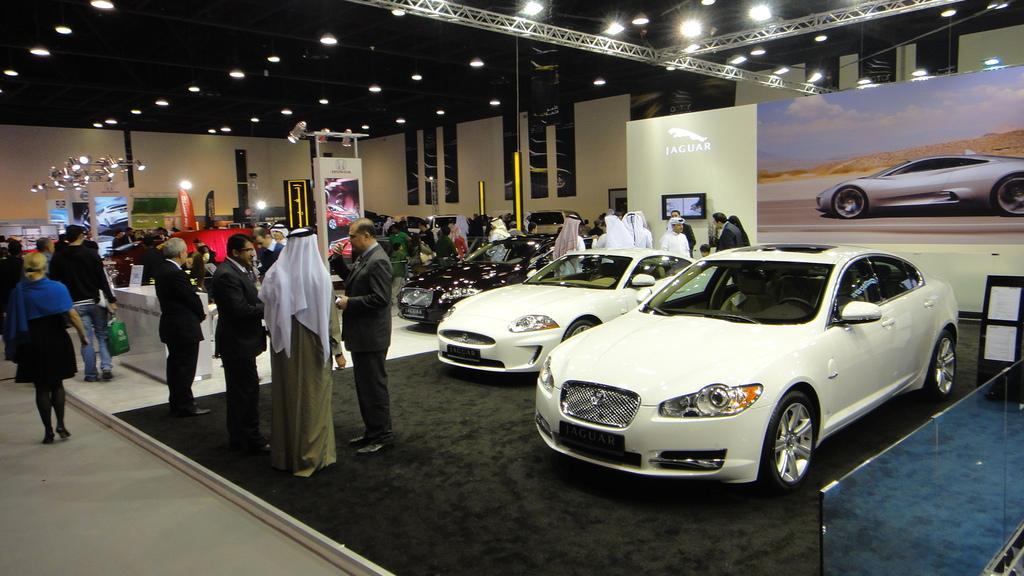In one or two sentences, can you explain what this image depicts? In the picture I can these cars are showcased here and these people are standing here. In the background, I can see a banner, a few more people walking on the floor, I can see tables, light poles and ceiling lights in the background. 